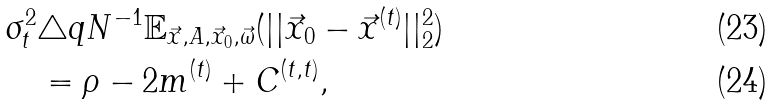<formula> <loc_0><loc_0><loc_500><loc_500>\sigma _ { t } ^ { 2 } & \triangle q N ^ { - 1 } \mathbb { E } _ { \vec { x } , A , \vec { x } _ { 0 } , \vec { \omega } } ( | | \vec { x } _ { 0 } - \vec { x } ^ { ( t ) } | | _ { 2 } ^ { 2 } ) \\ & = \rho - 2 m ^ { ( t ) } + C ^ { ( t , t ) } ,</formula> 